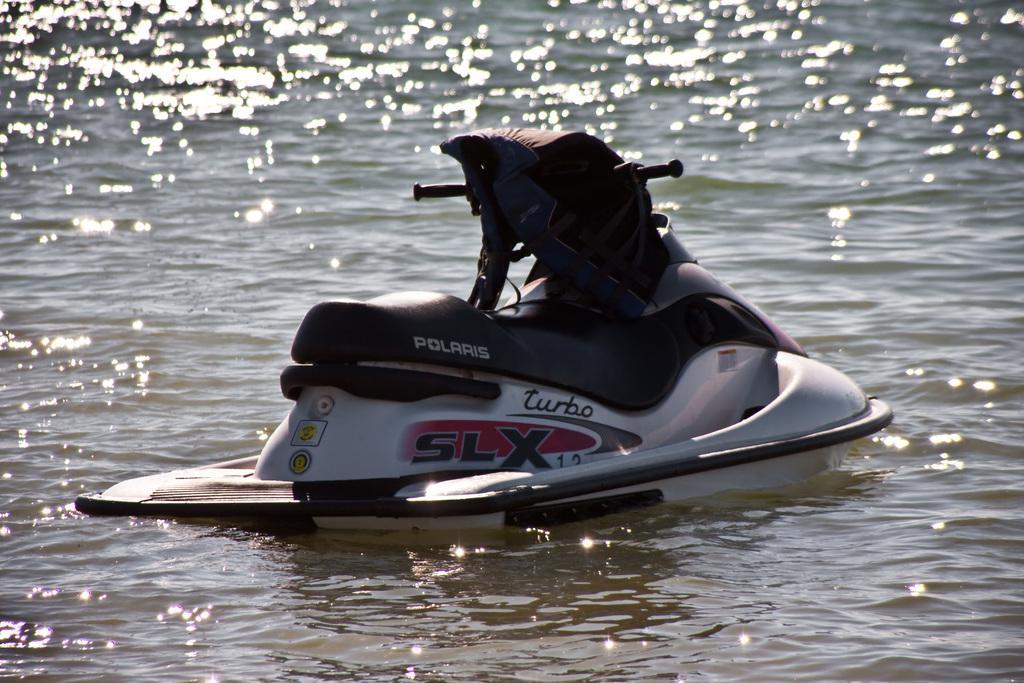Could you give a brief overview of what you see in this image? We can see boat above the water. 